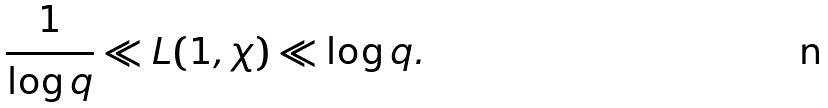<formula> <loc_0><loc_0><loc_500><loc_500>\frac { 1 } { \log q } \ll L ( 1 , \chi ) \ll \log q .</formula> 